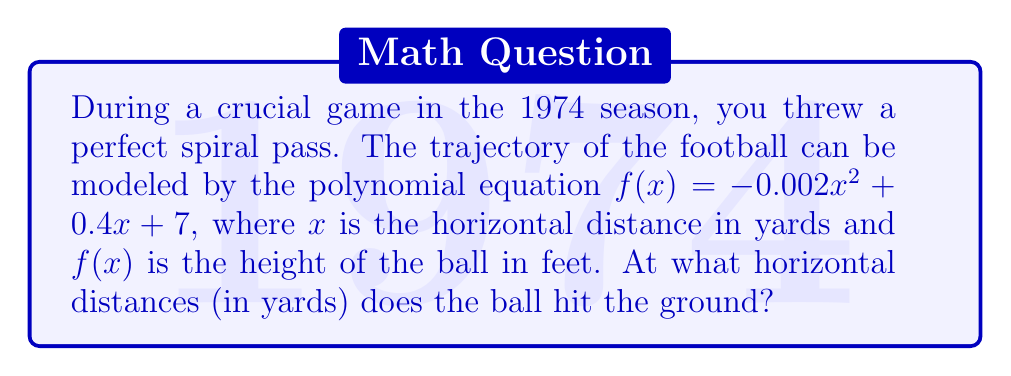Teach me how to tackle this problem. To find where the ball hits the ground, we need to solve the equation $f(x) = 0$. This is because the height of the ball is 0 when it touches the ground.

Let's solve $-0.002x^2 + 0.4x + 7 = 0$

1) First, multiply all terms by -500 to eliminate decimals:
   $x^2 - 200x - 3500 = 0$

2) This is a quadratic equation in the form $ax^2 + bx + c = 0$, where:
   $a = 1$, $b = -200$, and $c = -3500$

3) We can solve this using the quadratic formula: $x = \frac{-b \pm \sqrt{b^2 - 4ac}}{2a}$

4) Substituting our values:
   $x = \frac{200 \pm \sqrt{(-200)^2 - 4(1)(-3500)}}{2(1)}$

5) Simplify:
   $x = \frac{200 \pm \sqrt{40000 + 14000}}{2} = \frac{200 \pm \sqrt{54000}}{2}$

6) Simplify further:
   $x = \frac{200 \pm 232.38}{2}$

7) This gives us two solutions:
   $x_1 = \frac{200 + 232.38}{2} = 216.19$
   $x_2 = \frac{200 - 232.38}{2} = -16.19$

8) Since negative distance doesn't make sense in this context, we only consider the positive solution.

Therefore, the ball hits the ground approximately 216.19 yards from where it was thrown.
Answer: 216.19 yards 